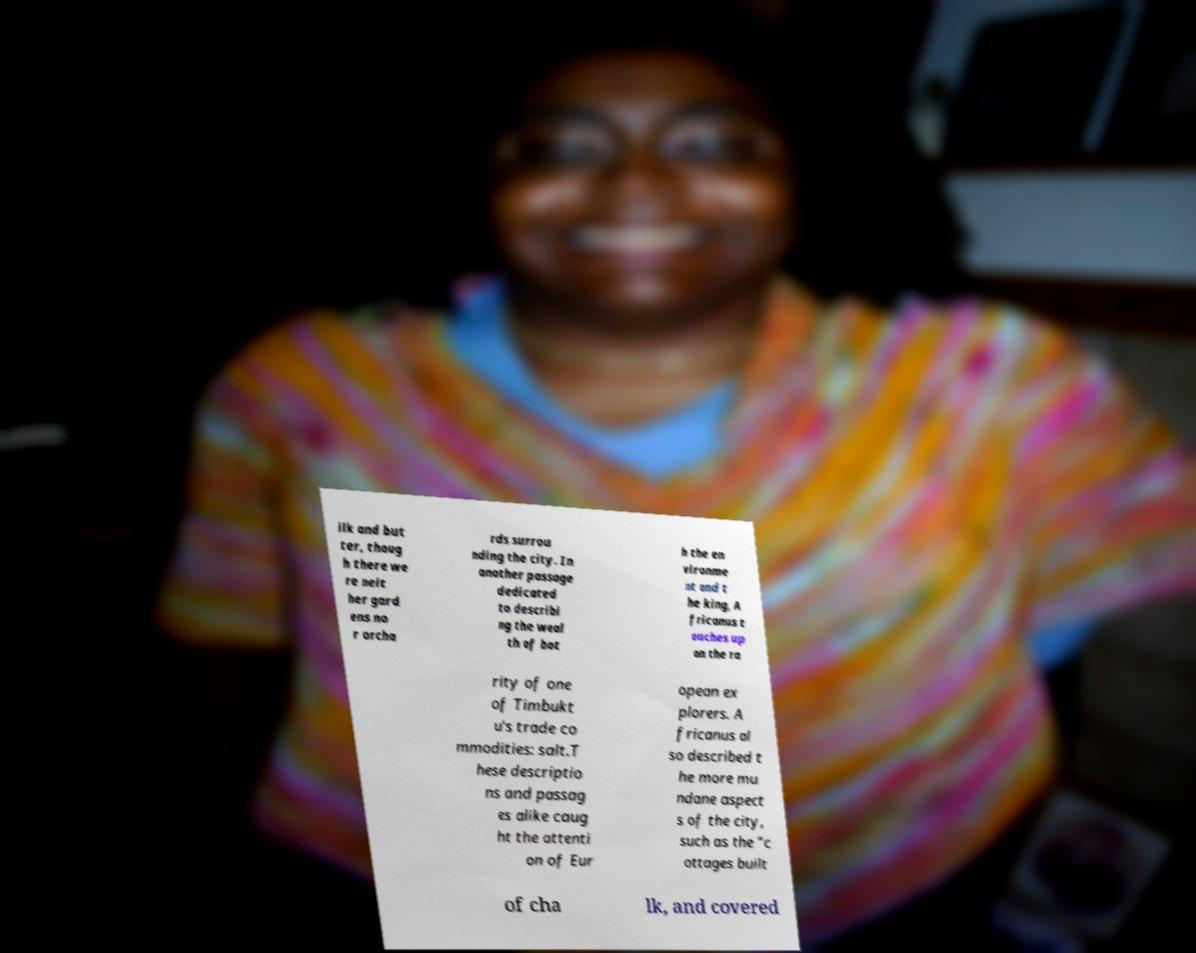Please identify and transcribe the text found in this image. ilk and but ter, thoug h there we re neit her gard ens no r orcha rds surrou nding the city. In another passage dedicated to describi ng the weal th of bot h the en vironme nt and t he king, A fricanus t ouches up on the ra rity of one of Timbukt u's trade co mmodities: salt.T hese descriptio ns and passag es alike caug ht the attenti on of Eur opean ex plorers. A fricanus al so described t he more mu ndane aspect s of the city, such as the "c ottages built of cha lk, and covered 